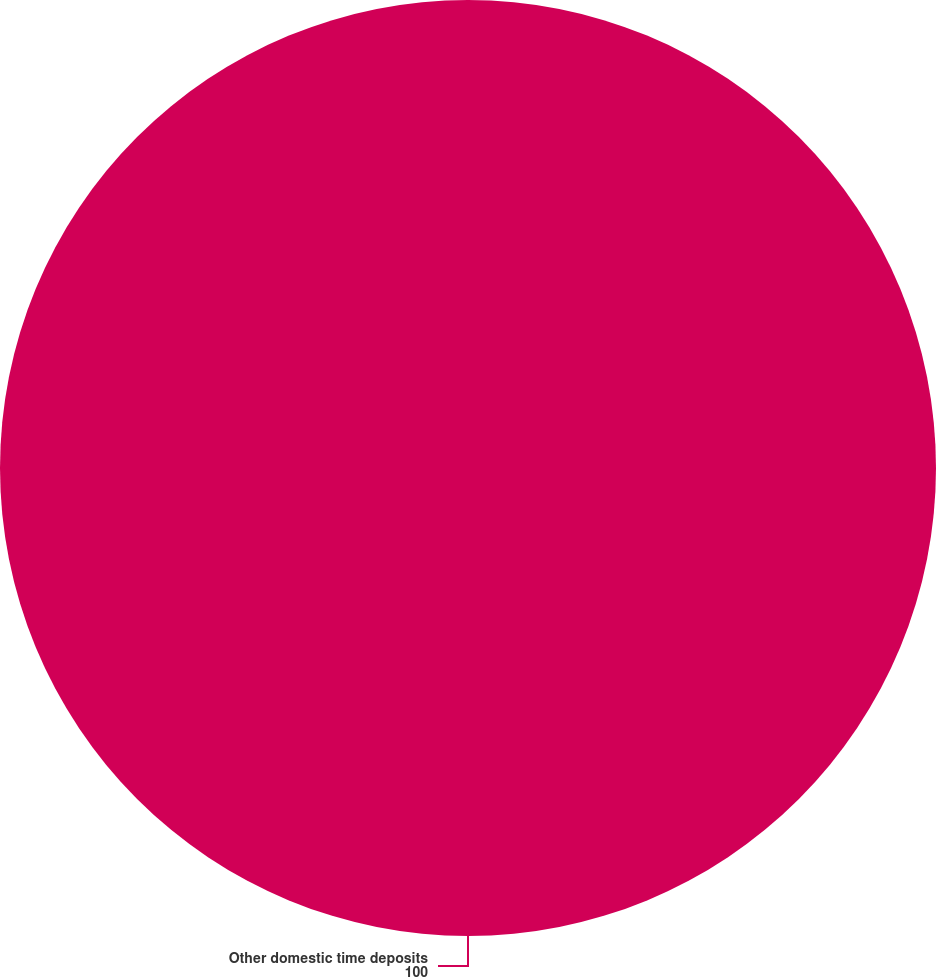Convert chart to OTSL. <chart><loc_0><loc_0><loc_500><loc_500><pie_chart><fcel>Other domestic time deposits<nl><fcel>100.0%<nl></chart> 